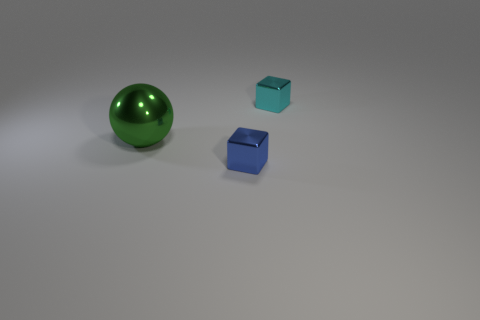What is the size of the cyan metal object that is the same shape as the blue object?
Keep it short and to the point. Small. How many big green spheres are the same material as the small cyan object?
Your response must be concise. 1. What material is the cyan block?
Keep it short and to the point. Metal. There is a small metallic thing that is left of the metallic object that is behind the sphere; what is its shape?
Give a very brief answer. Cube. What shape is the small metal object that is left of the cyan object?
Give a very brief answer. Cube. The large sphere is what color?
Provide a succinct answer. Green. There is a metal block in front of the cyan cube; how many tiny cyan blocks are in front of it?
Offer a terse response. 0. Is the size of the green metal object the same as the thing in front of the sphere?
Keep it short and to the point. No. Is the blue shiny cube the same size as the cyan shiny object?
Keep it short and to the point. Yes. Is there a green ball that has the same size as the blue thing?
Ensure brevity in your answer.  No. 